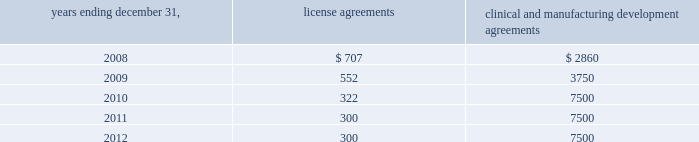Alexion pharmaceuticals , inc .
Notes to consolidated financial statements 2014 ( continued ) for the years ended december 31 , 2007 and 2006 , five month period ended december 31 , 2005 , and year ended july 31 , 2005 ( amounts in thousands , except share and per share amounts ) in 2006 , we completed a final phase iii trial of pexelizumab .
After reviewing results from that trial , we along with p&g , determined not to pursue further development of pexelizumab .
Effective march 30 , 2007 , we and p&g mutually agreed to terminate the collaboration agreement .
As the relevant agreement has been terminated in march 2007 , the remaining portion of the $ 10000 non-refundable up-front license fee , or $ 5343 , was recognized as revenue in the year ended december 31 , 2007 and is included in contract research revenues .
License and research and development agreements we have entered into a number of license , research and development and manufacturing development agreements since our inception .
These agreements have been made with various research institutions , universities , contractors , collaborators , and government agencies in order to advance and obtain technologies and services related to our business .
License agreements generally provide for an initial fee followed by annual minimum royalty payments .
Additionally , certain agreements call for future payments upon the attainment of agreed upon milestones , such as , but not limited to , investigational new drug , or ind , application or approval of biologics license application .
These agreements require minimum royalty payments based on sales of products developed from the applicable technologies , if any .
Clinical and manufacturing development agreements generally provide for us to fund manufacturing development and on-going clinical trials .
Clinical trial and development agreements include contract services and outside contractor services including contracted clinical site services related to patient enrolment for our clinical trials .
Manufacturing development agreements include clinical manufacturing and manufacturing development and scale-up .
We have executed a large-scale product supply agreement with lonza sales ag for the long-term commercial manufacture of soliris ( see note 9 ) .
In order to maintain our rights under these agreements , we may be required to provide a minimum level of funding or support .
We may elect to terminate these arrangements .
Accordingly , we recognize the expense and related obligation related to these arrangements over the period of performance .
The minimum fixed payments ( assuming non-termination of the above agreements ) as of december 31 , 2007 , for each of the next five years are as follows : years ending december 31 , license agreements clinical and manufacturing development agreements .

What is the percent change in minimum fixed payments of clinical and manufacturing development agreements between 2008 and 2009? 
Computations: ((3750 - 2860) / 2860)
Answer: 0.31119. 